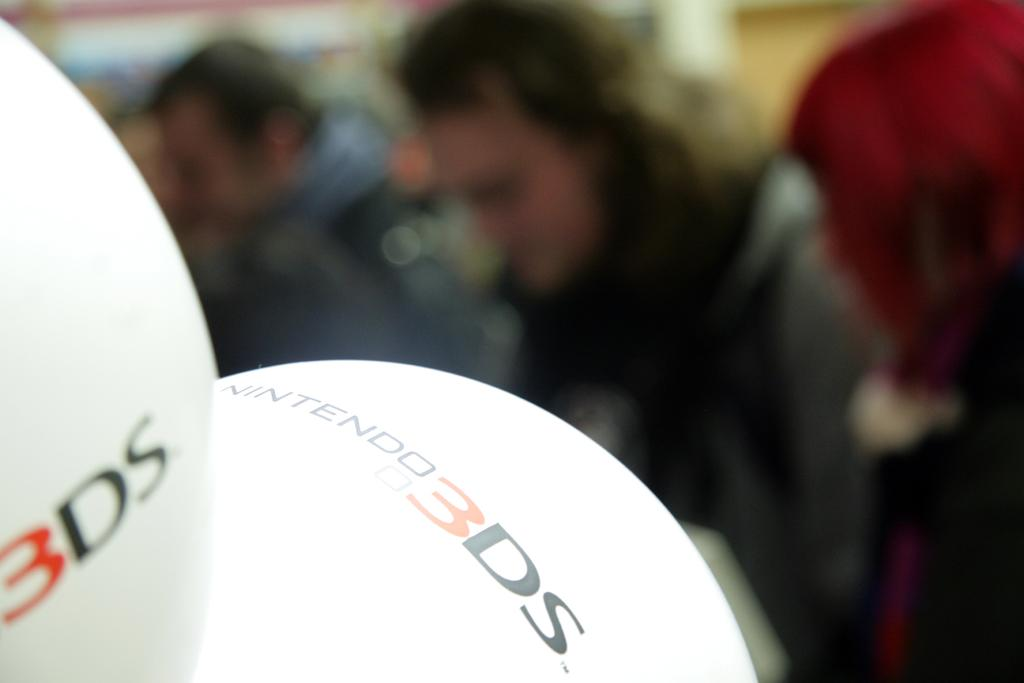Who or what can be seen in the image? There are people in the image. What else is present in the image besides the people? There are balloons in the image. What color is the paint on the pigs in the image? There are no pigs or paint present in the image. 